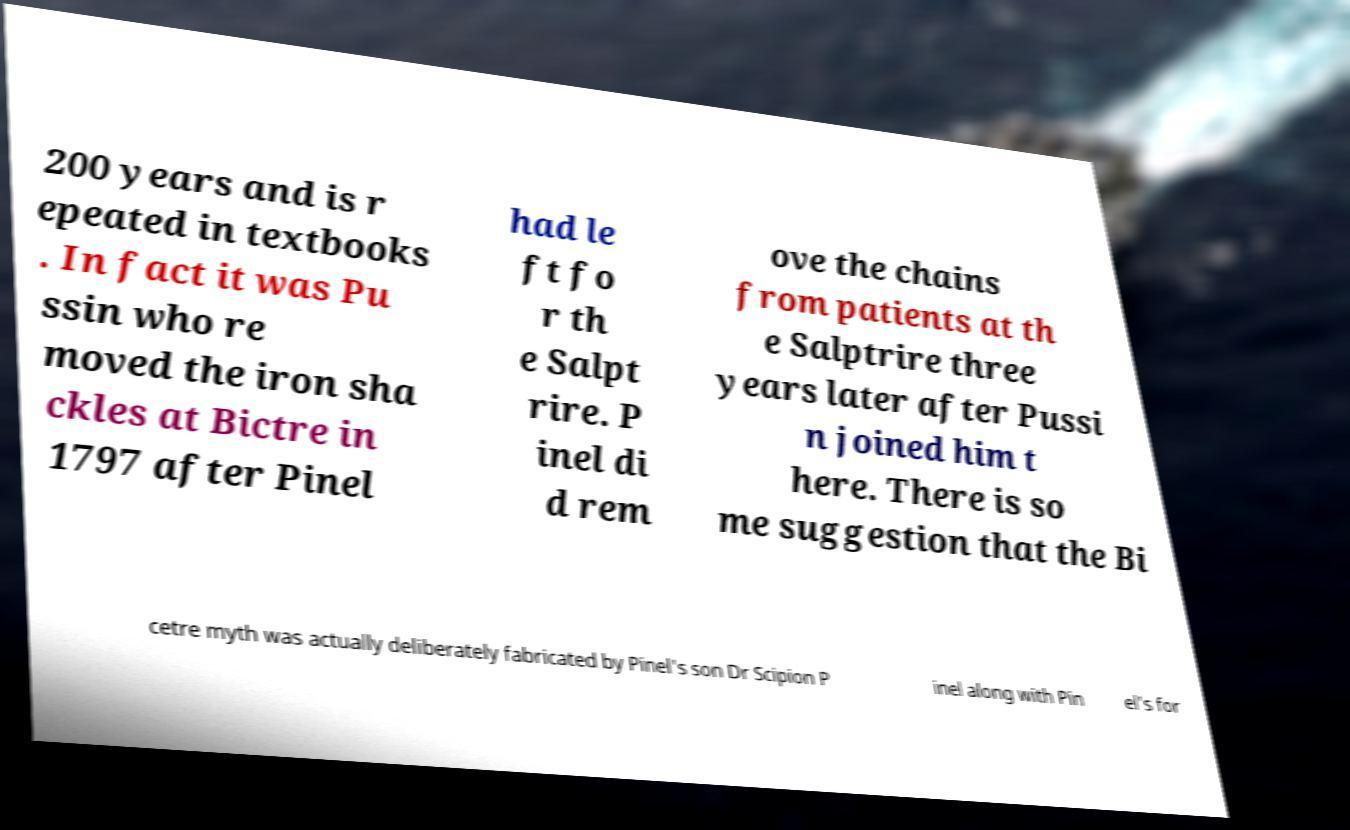There's text embedded in this image that I need extracted. Can you transcribe it verbatim? 200 years and is r epeated in textbooks . In fact it was Pu ssin who re moved the iron sha ckles at Bictre in 1797 after Pinel had le ft fo r th e Salpt rire. P inel di d rem ove the chains from patients at th e Salptrire three years later after Pussi n joined him t here. There is so me suggestion that the Bi cetre myth was actually deliberately fabricated by Pinel's son Dr Scipion P inel along with Pin el's for 